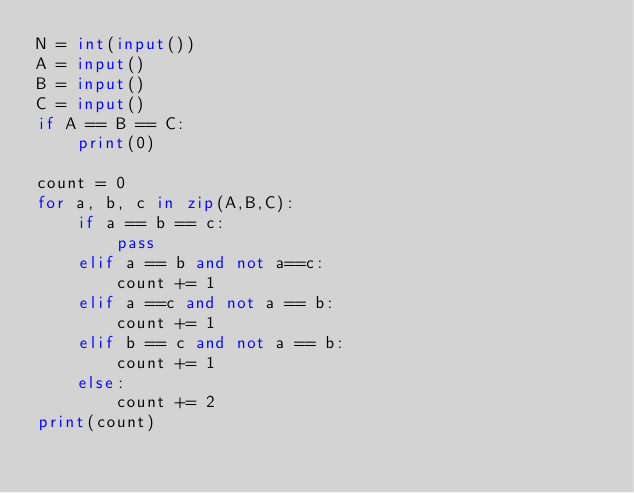<code> <loc_0><loc_0><loc_500><loc_500><_Python_>N = int(input())
A = input()
B = input()
C = input()
if A == B == C:
    print(0)

count = 0
for a, b, c in zip(A,B,C):
    if a == b == c:
        pass
    elif a == b and not a==c:
        count += 1
    elif a ==c and not a == b:
        count += 1
    elif b == c and not a == b:
        count += 1
    else:
        count += 2
print(count)</code> 